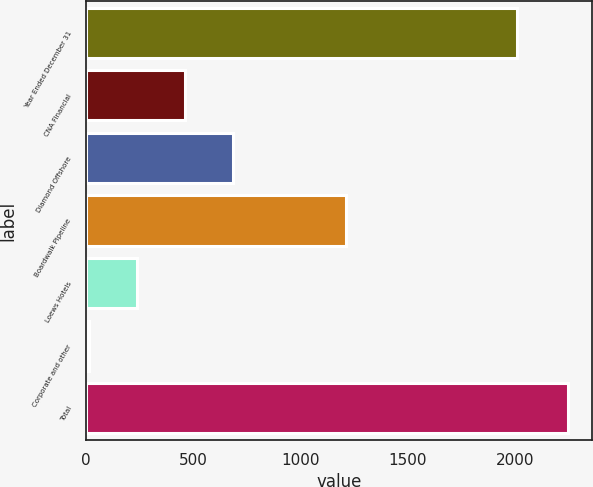<chart> <loc_0><loc_0><loc_500><loc_500><bar_chart><fcel>Year Ended December 31<fcel>CNA Financial<fcel>Diamond Offshore<fcel>Boardwalk Pipeline<fcel>Loews Hotels<fcel>Corporate and other<fcel>Total<nl><fcel>2007<fcel>460.6<fcel>683.9<fcel>1214<fcel>237.3<fcel>14<fcel>2247<nl></chart> 